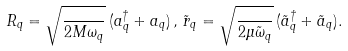<formula> <loc_0><loc_0><loc_500><loc_500>R _ { q } = \sqrt { \frac { } { 2 M \omega _ { q } } } \, ( a _ { q } ^ { \dagger } + a _ { q } ) \, , \, \tilde { r } _ { q } = \sqrt { \frac { } { 2 \mu \tilde { \omega } _ { q } } } \, ( \tilde { a } _ { q } ^ { \dagger } + \tilde { a } _ { q } ) .</formula> 